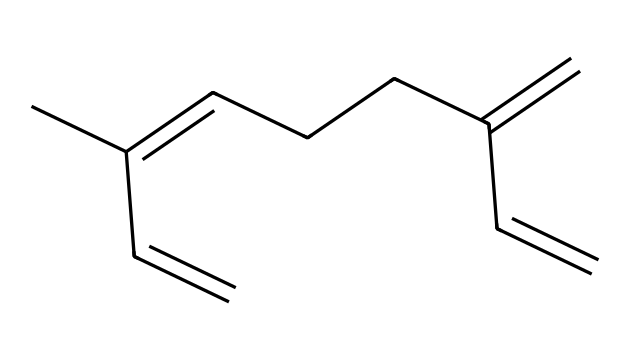How many carbon atoms are in myrcene? By analyzing the SMILES representation, we can count the number of carbon atoms (C). The structure includes 10 carbon atoms in total.
Answer: 10 What is the degree of unsaturation in myrcene? The degree of unsaturation can be calculated using the formula (2C + 2 - H) / 2. For myrcene, there are 10 carbons and 14 hydrogens, giving (2(10) + 2 - 14) / 2 = 4. This means there are 4 degrees of unsaturation, which indicates the presence of rings and/or double bonds.
Answer: 4 Does myrcene contain any double bonds? Yes, the SMILES representation indicates multiple double bonds in the structure, as denoted by the equals sign (=).
Answer: Yes What type of compound is myrcene classified as? Terpenes are classified primarily based on their molecular structure. Given that myrcene contains a series of interconnected carbon atoms and engages in the characteristics of terpenes, it is classified as a terpene.
Answer: terpene What is a key structural feature of myrcene that contributes to its aroma? Myrcene features a series of carbon-carbon double bonds that enhance its aromatic profile, contributing to its musky and earthy scent typically found in hops and craft beers.
Answer: double bonds 